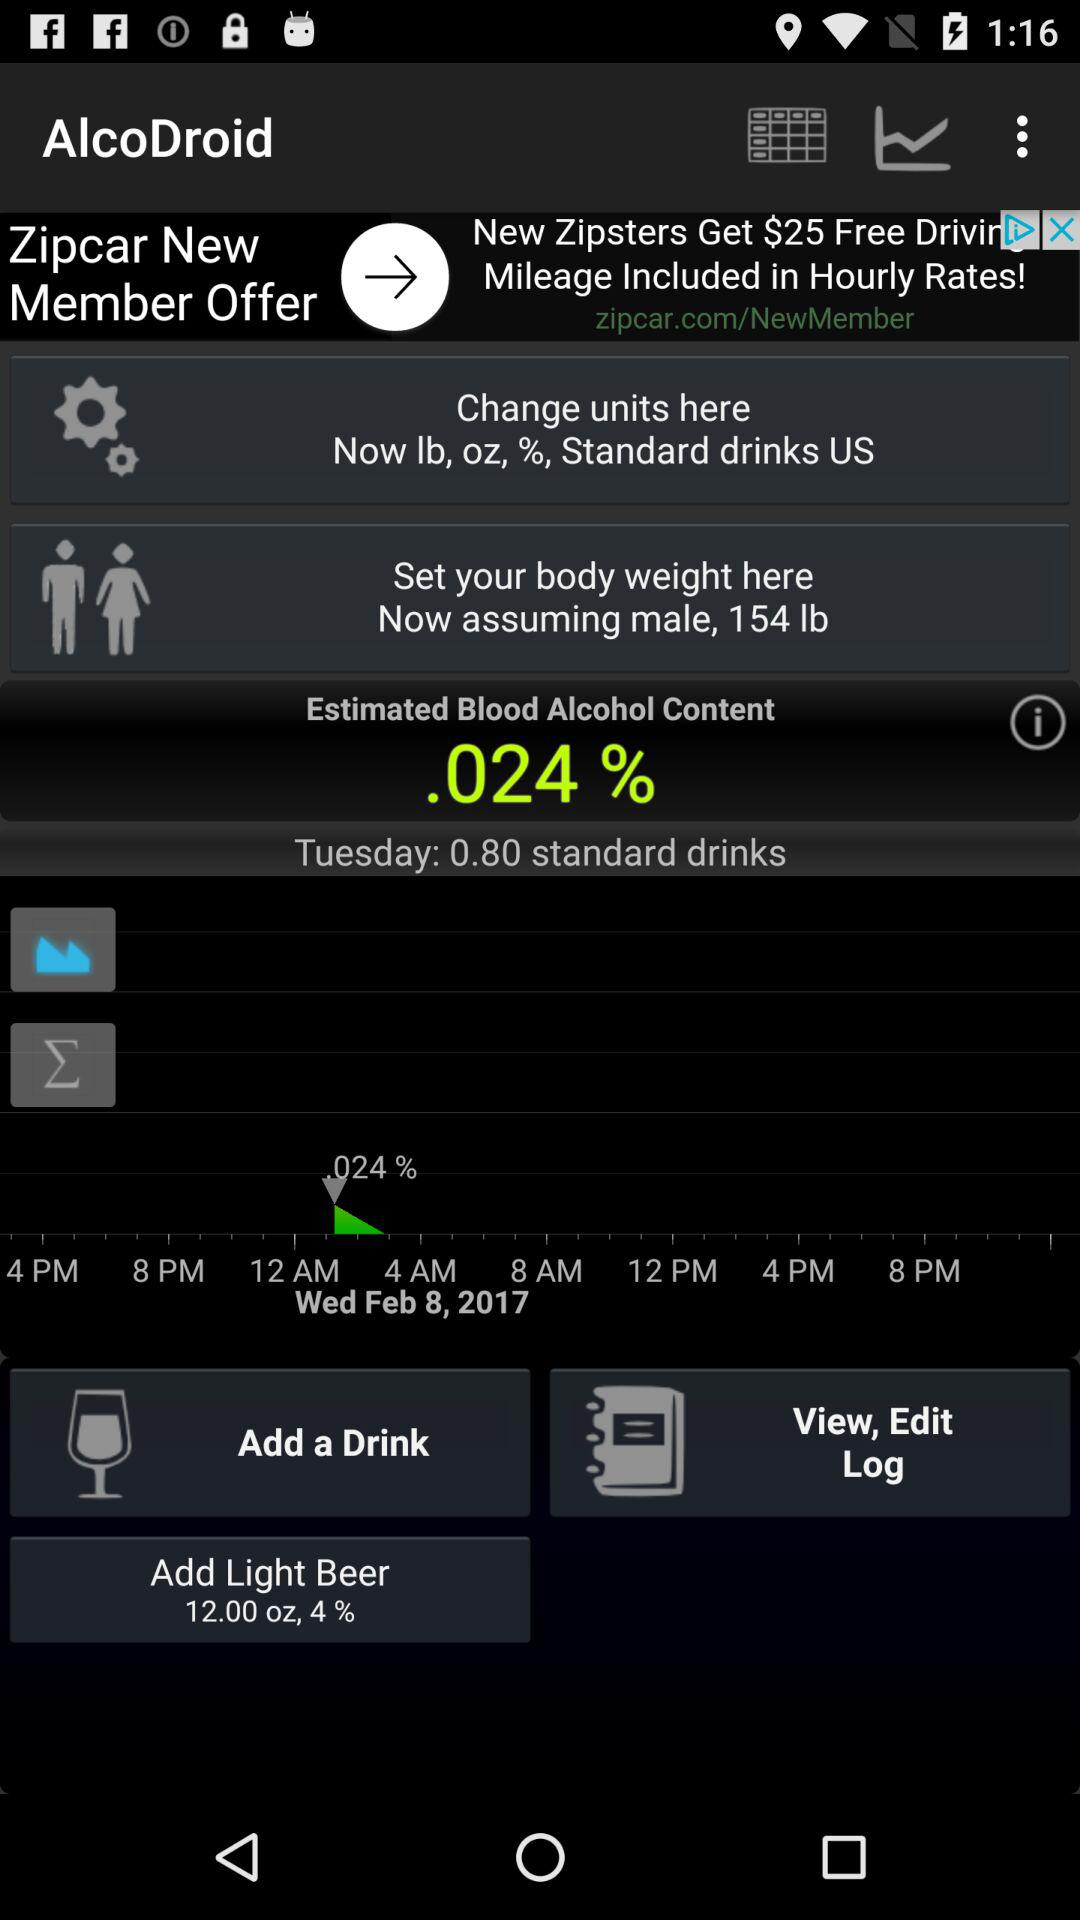What is the percentage of light beer that needs to be added? The percentage of light beer that needs to be added is 4. 